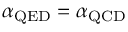Convert formula to latex. <formula><loc_0><loc_0><loc_500><loc_500>\alpha _ { Q E D } = \alpha _ { Q C D }</formula> 